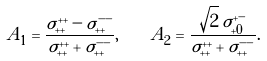Convert formula to latex. <formula><loc_0><loc_0><loc_500><loc_500>A _ { 1 } = \frac { \sigma _ { + + } ^ { + + } - \sigma _ { + + } ^ { - - } } { \sigma _ { + + } ^ { + + } + \sigma _ { + + } ^ { - - } } , \quad A _ { 2 } = \frac { \sqrt { 2 } \, \sigma _ { + 0 } ^ { + - } } { \sigma _ { + + } ^ { + + } + \sigma _ { + + } ^ { - - } } .</formula> 